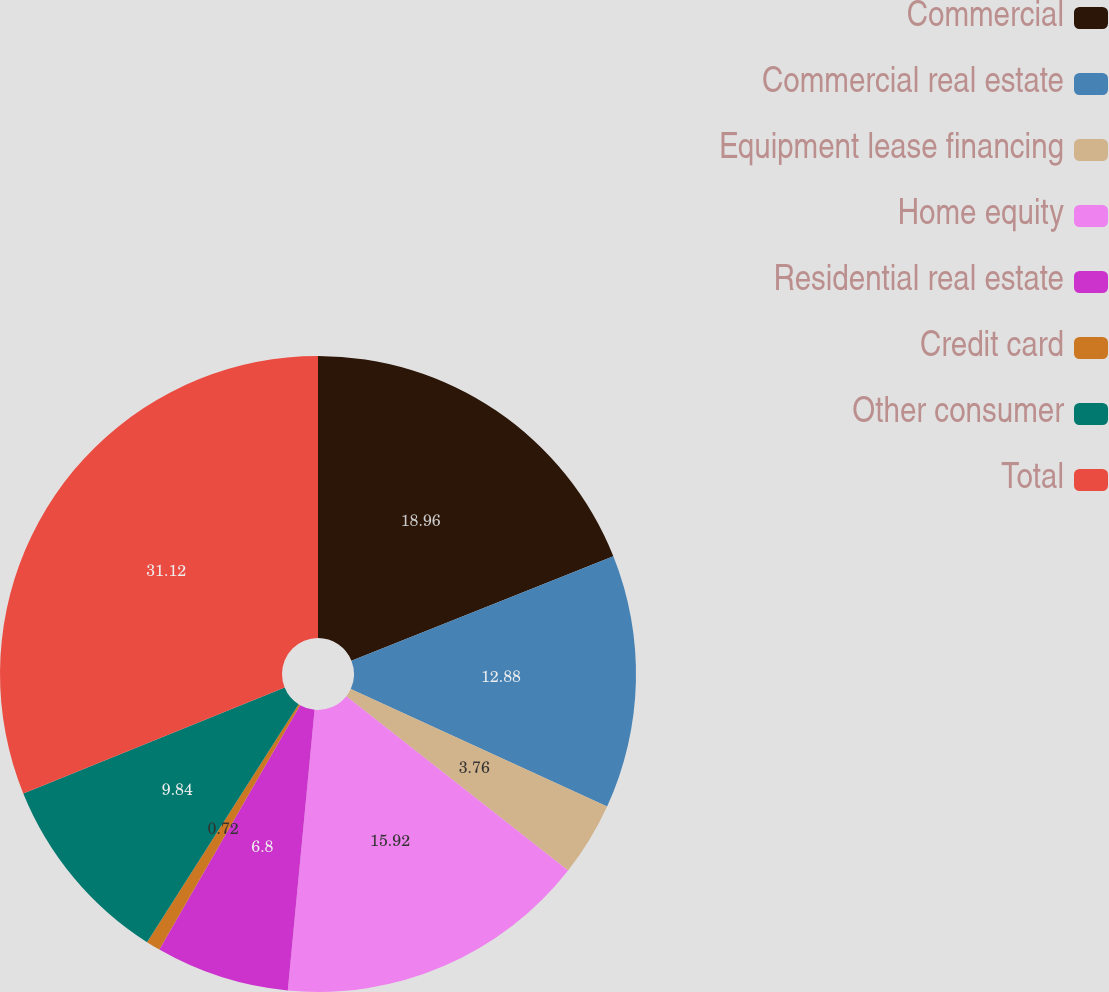Convert chart. <chart><loc_0><loc_0><loc_500><loc_500><pie_chart><fcel>Commercial<fcel>Commercial real estate<fcel>Equipment lease financing<fcel>Home equity<fcel>Residential real estate<fcel>Credit card<fcel>Other consumer<fcel>Total<nl><fcel>18.96%<fcel>12.88%<fcel>3.76%<fcel>15.92%<fcel>6.8%<fcel>0.72%<fcel>9.84%<fcel>31.13%<nl></chart> 